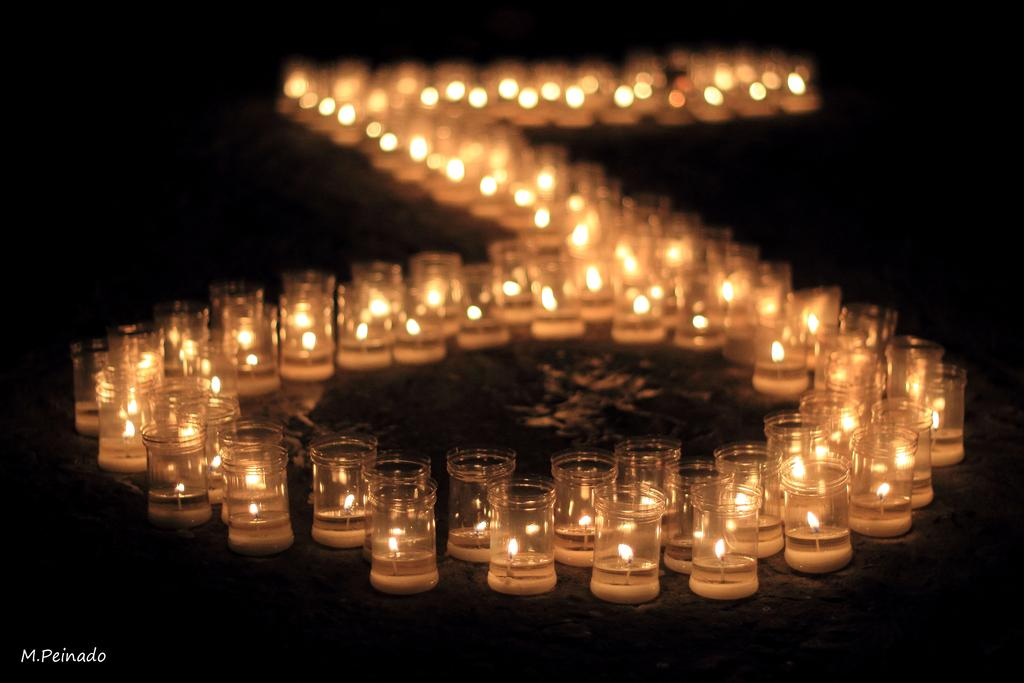What objects are in the glasses in the image? There are candles in the glasses in the image. What is the state of the candles? The candles have fire. How would you describe the overall lighting in the image? The background of the image is dark. Is there any additional information or branding present in the image? Yes, there is a watermark in the bottom left corner of the image. What type of dirt can be seen on the rose in the image? There is no rose present in the image, and therefore no dirt can be observed on it. How old is the baby in the image? There is no baby present in the image. 